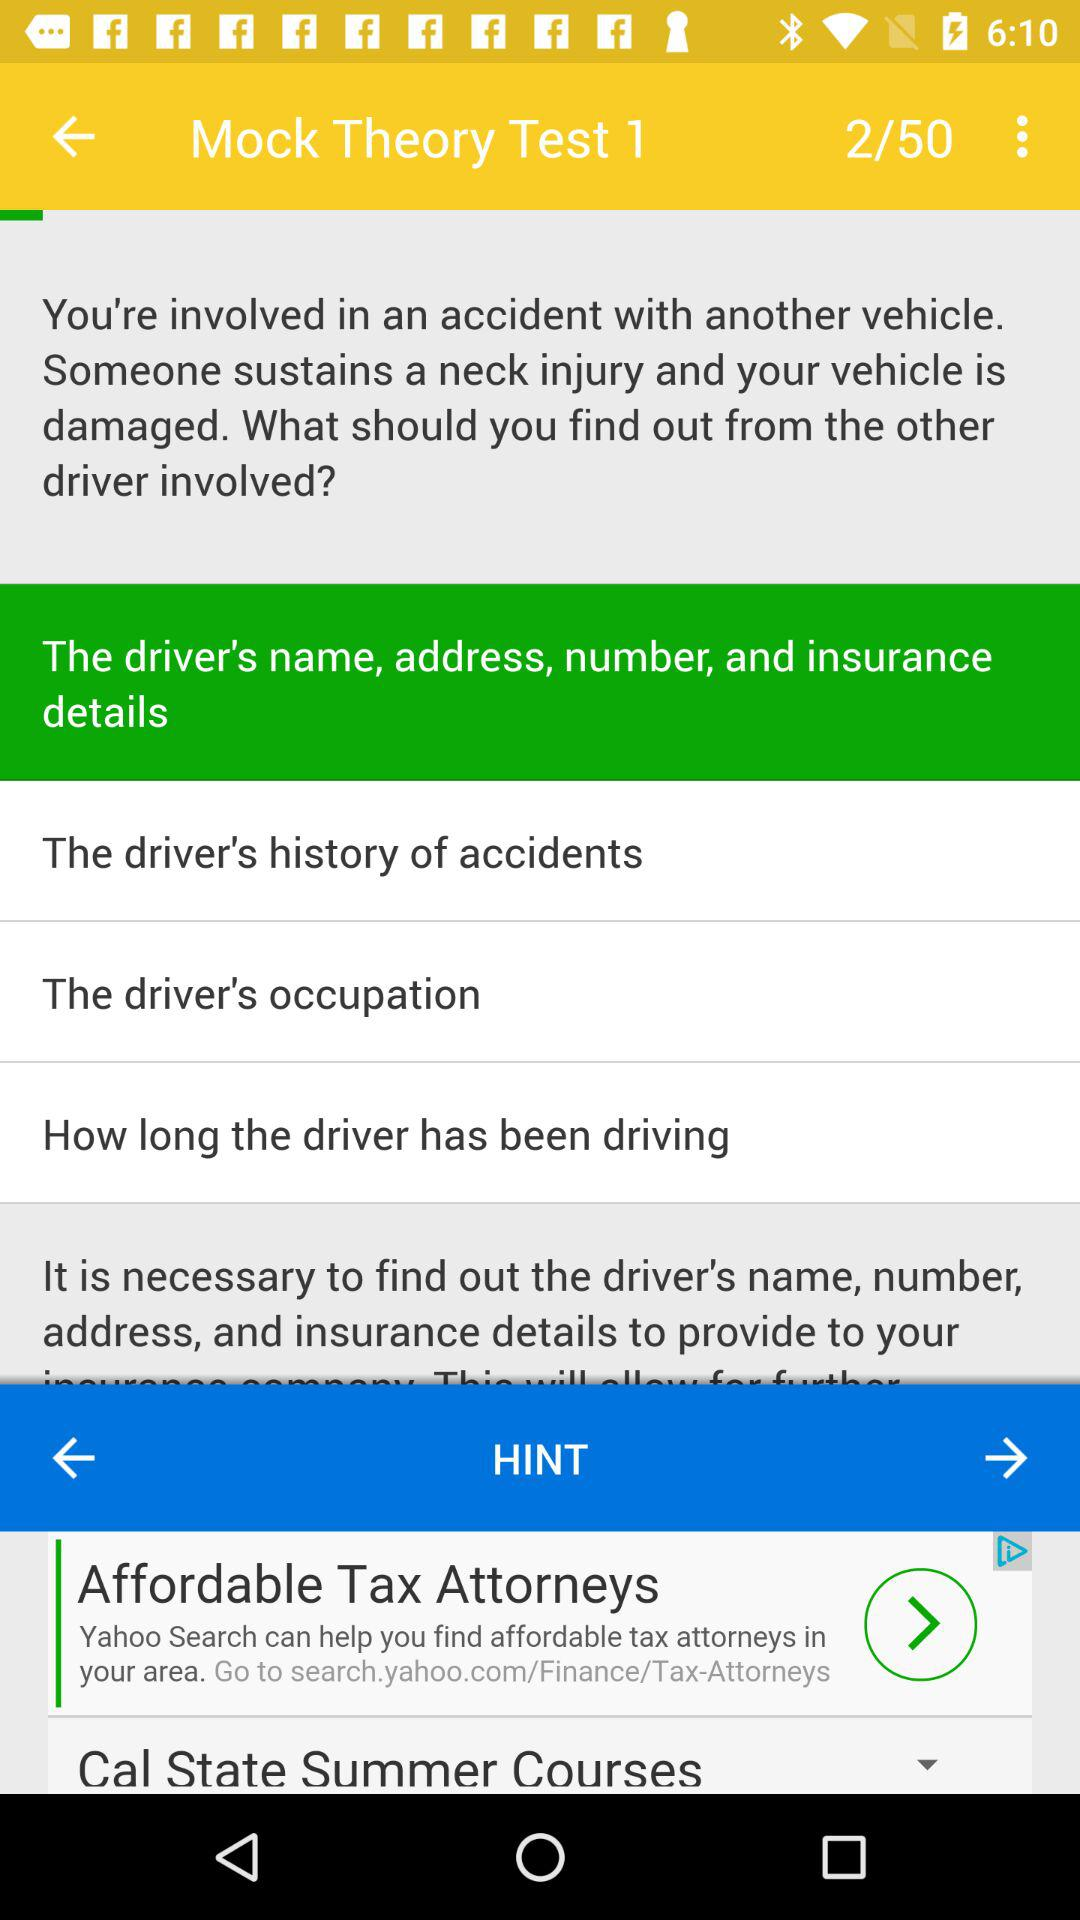How many pages in total are there? There are 50 pages. 